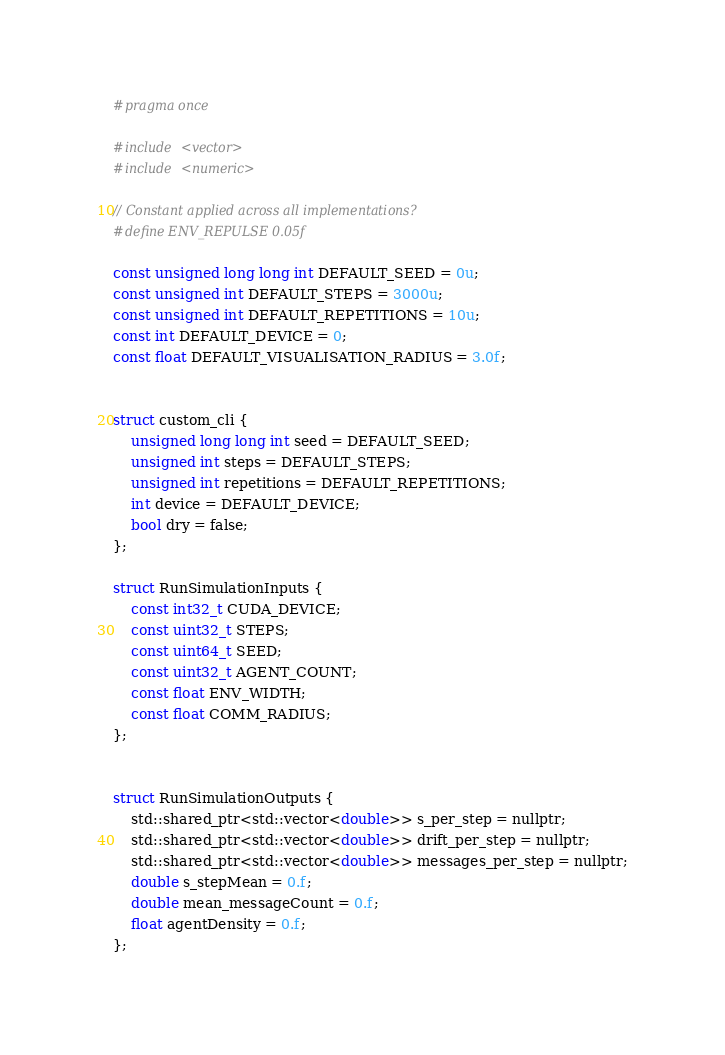<code> <loc_0><loc_0><loc_500><loc_500><_Cuda_>#pragma once

#include <vector>
#include <numeric>

// Constant applied across all implementations?
#define ENV_REPULSE 0.05f

const unsigned long long int DEFAULT_SEED = 0u;
const unsigned int DEFAULT_STEPS = 3000u;
const unsigned int DEFAULT_REPETITIONS = 10u;
const int DEFAULT_DEVICE = 0;
const float DEFAULT_VISUALISATION_RADIUS = 3.0f;


struct custom_cli {
    unsigned long long int seed = DEFAULT_SEED;
    unsigned int steps = DEFAULT_STEPS;
    unsigned int repetitions = DEFAULT_REPETITIONS;
    int device = DEFAULT_DEVICE;
    bool dry = false;
};

struct RunSimulationInputs {
    const int32_t CUDA_DEVICE;
    const uint32_t STEPS;
    const uint64_t SEED;
    const uint32_t AGENT_COUNT;
    const float ENV_WIDTH;
    const float COMM_RADIUS;
};


struct RunSimulationOutputs { 
    std::shared_ptr<std::vector<double>> s_per_step = nullptr;
    std::shared_ptr<std::vector<double>> drift_per_step = nullptr;
    std::shared_ptr<std::vector<double>> messages_per_step = nullptr;
    double s_stepMean = 0.f;
    double mean_messageCount = 0.f;
    float agentDensity = 0.f;
};
</code> 